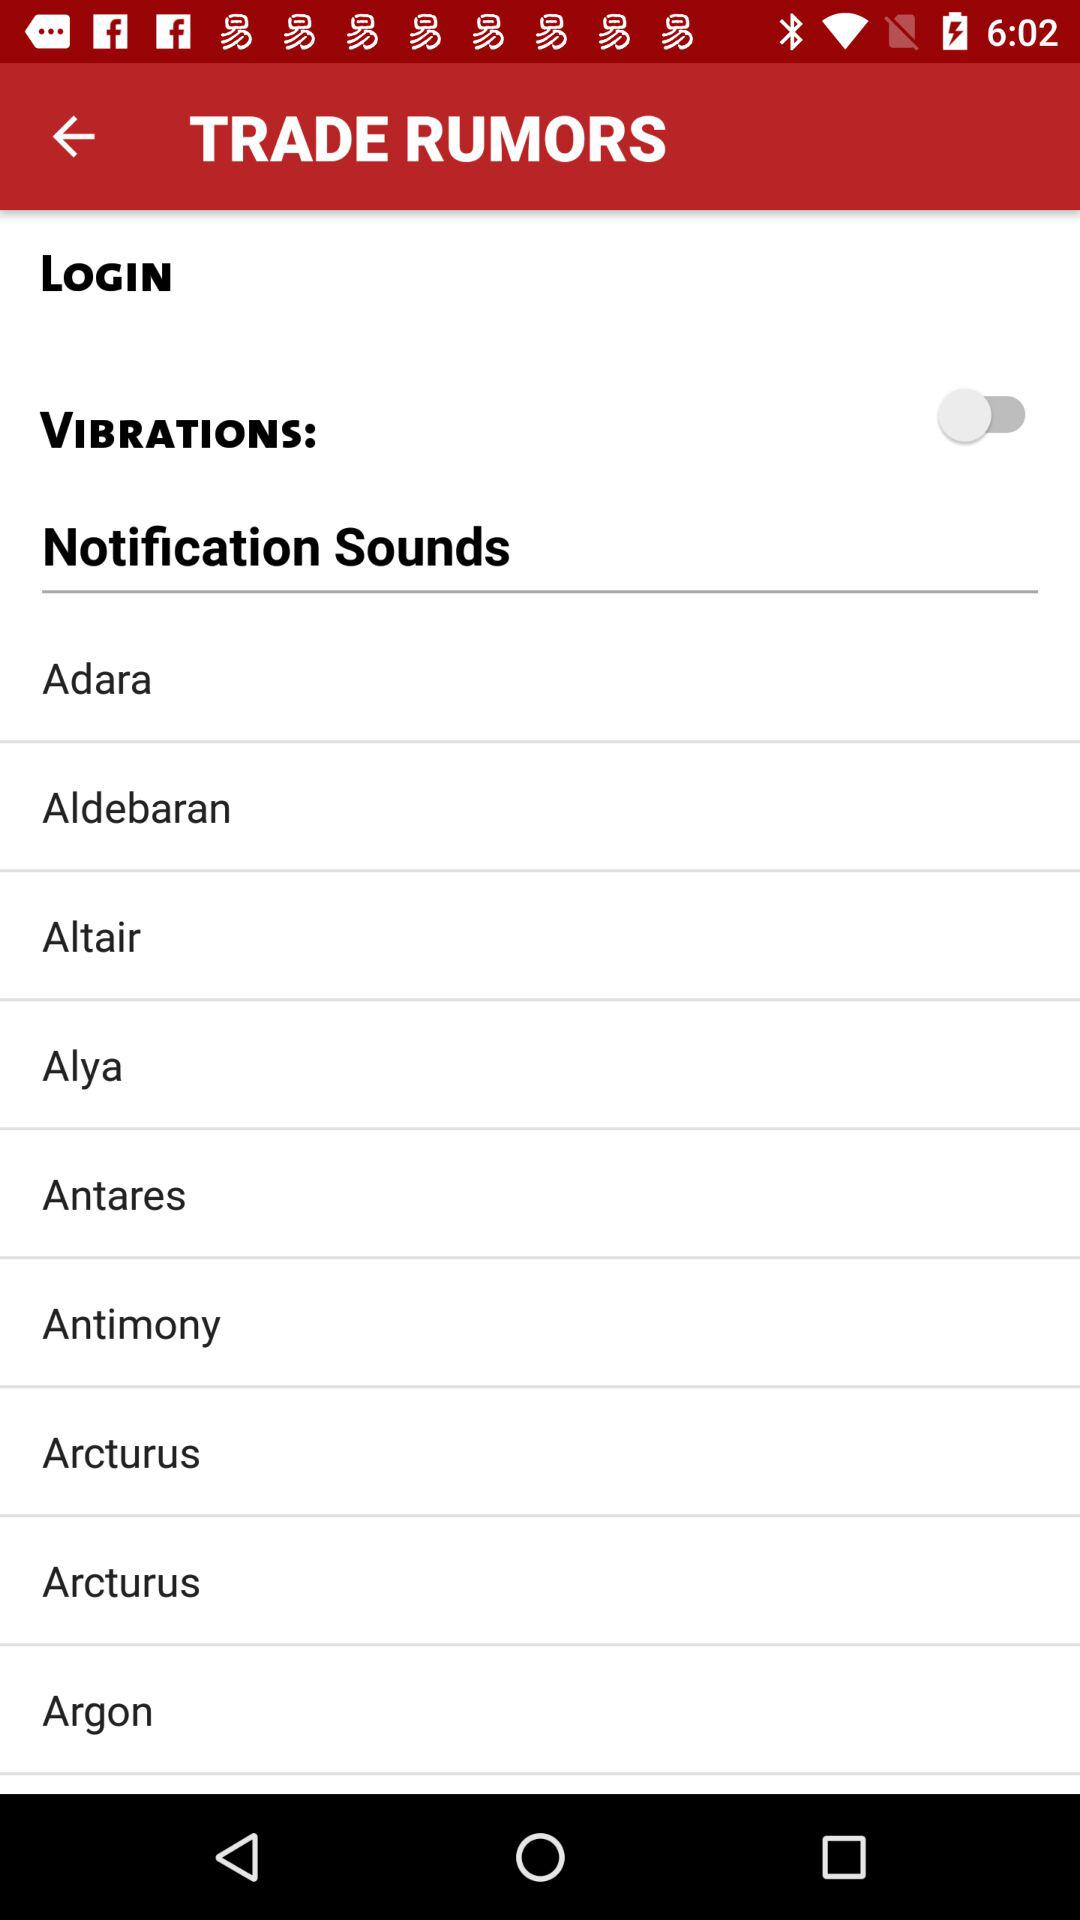What is the status of "VIBRATIONS"? The status is "off". 